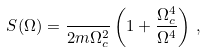<formula> <loc_0><loc_0><loc_500><loc_500>S ( \Omega ) = \frac { } { 2 m \Omega _ { c } ^ { 2 } } \left ( 1 + \frac { \Omega _ { c } ^ { 4 } } { \Omega ^ { 4 } } \right ) \, ,</formula> 